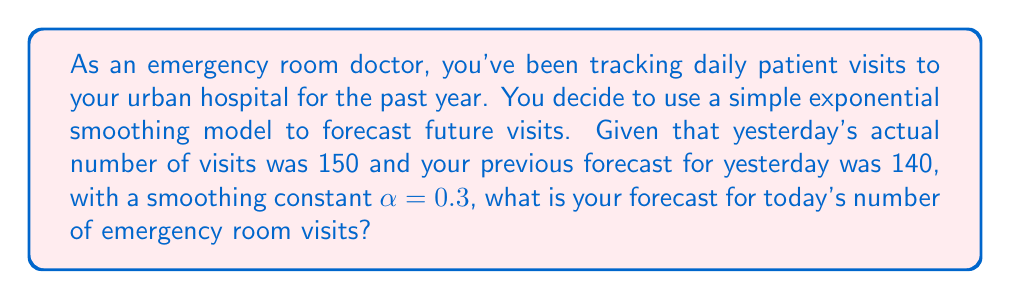Show me your answer to this math problem. To solve this problem, we'll use the simple exponential smoothing formula:

$$F_t = \alpha Y_{t-1} + (1-\alpha)F_{t-1}$$

Where:
$F_t$ is the forecast for the current period
$\alpha$ is the smoothing constant (0 < $\alpha$ < 1)
$Y_{t-1}$ is the actual value of the previous period
$F_{t-1}$ is the forecast for the previous period

Given:
$\alpha = 0.3$
$Y_{t-1} = 150$ (yesterday's actual visits)
$F_{t-1} = 140$ (previous forecast for yesterday)

Let's substitute these values into the formula:

$$\begin{align}
F_t &= 0.3 \times 150 + (1-0.3) \times 140 \\
&= 45 + 0.7 \times 140 \\
&= 45 + 98 \\
&= 143
\end{align}$$

Therefore, the forecast for today's emergency room visits is 143.
Answer: 143 visits 